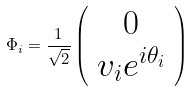Convert formula to latex. <formula><loc_0><loc_0><loc_500><loc_500>\Phi _ { i } = { \frac { 1 } { \sqrt { 2 } } } \left ( \begin{array} { c } { 0 } \\ { { v _ { i } e ^ { i \theta _ { i } } } } \end{array} \right )</formula> 